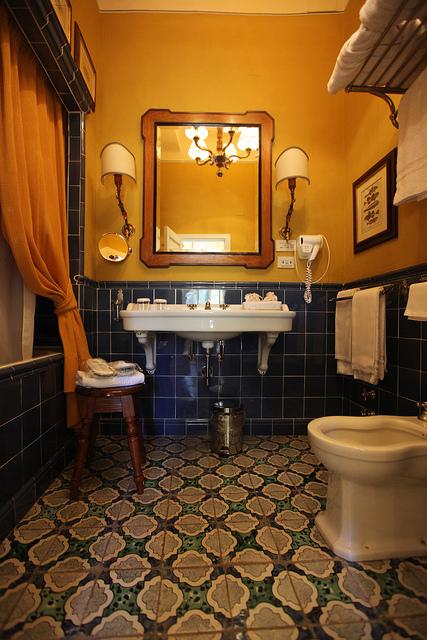Would a poor person be using this?
Concise answer only. No. Where is the mirror?
Keep it brief. Above sink. What is in the top of the mirror reflection?
Give a very brief answer. Light. 